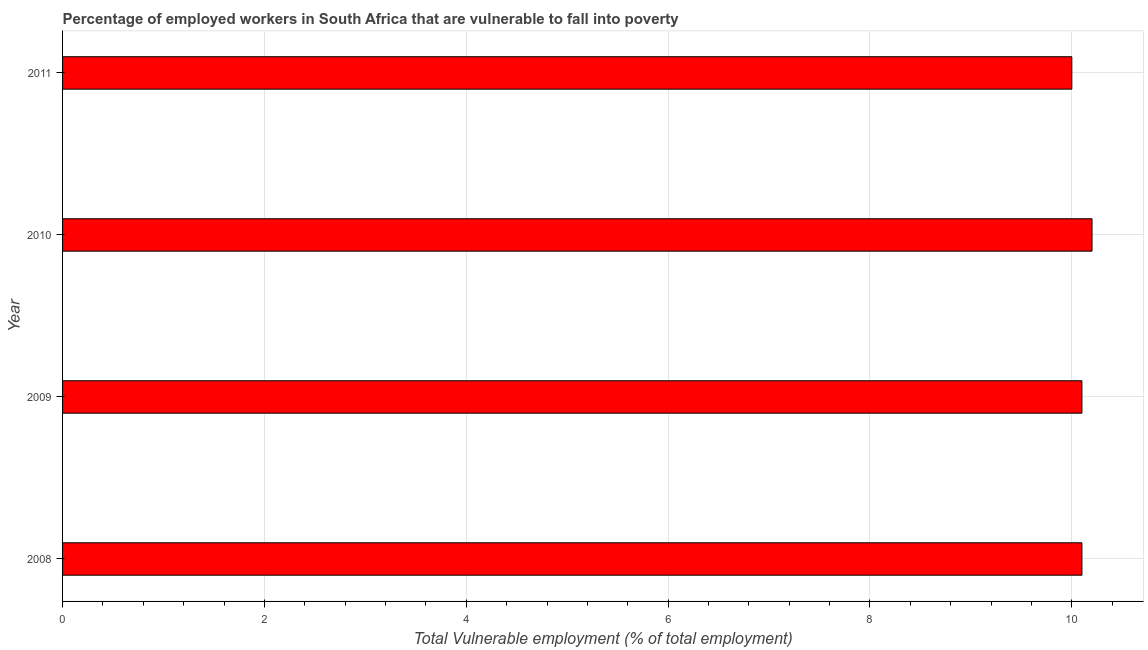Does the graph contain grids?
Provide a short and direct response. Yes. What is the title of the graph?
Offer a very short reply. Percentage of employed workers in South Africa that are vulnerable to fall into poverty. What is the label or title of the X-axis?
Offer a terse response. Total Vulnerable employment (% of total employment). What is the label or title of the Y-axis?
Keep it short and to the point. Year. What is the total vulnerable employment in 2008?
Ensure brevity in your answer.  10.1. Across all years, what is the maximum total vulnerable employment?
Make the answer very short. 10.2. What is the sum of the total vulnerable employment?
Make the answer very short. 40.4. What is the median total vulnerable employment?
Your response must be concise. 10.1. What is the ratio of the total vulnerable employment in 2008 to that in 2011?
Provide a short and direct response. 1.01. What is the difference between the highest and the second highest total vulnerable employment?
Provide a short and direct response. 0.1. Is the sum of the total vulnerable employment in 2010 and 2011 greater than the maximum total vulnerable employment across all years?
Offer a very short reply. Yes. What is the difference between the highest and the lowest total vulnerable employment?
Keep it short and to the point. 0.2. How many bars are there?
Your response must be concise. 4. Are all the bars in the graph horizontal?
Provide a succinct answer. Yes. How many years are there in the graph?
Provide a short and direct response. 4. Are the values on the major ticks of X-axis written in scientific E-notation?
Keep it short and to the point. No. What is the Total Vulnerable employment (% of total employment) of 2008?
Offer a terse response. 10.1. What is the Total Vulnerable employment (% of total employment) in 2009?
Your answer should be compact. 10.1. What is the Total Vulnerable employment (% of total employment) of 2010?
Make the answer very short. 10.2. What is the Total Vulnerable employment (% of total employment) in 2011?
Your response must be concise. 10. What is the difference between the Total Vulnerable employment (% of total employment) in 2008 and 2010?
Provide a succinct answer. -0.1. What is the difference between the Total Vulnerable employment (% of total employment) in 2008 and 2011?
Make the answer very short. 0.1. What is the difference between the Total Vulnerable employment (% of total employment) in 2010 and 2011?
Your answer should be compact. 0.2. What is the ratio of the Total Vulnerable employment (% of total employment) in 2008 to that in 2009?
Offer a very short reply. 1. What is the ratio of the Total Vulnerable employment (% of total employment) in 2008 to that in 2011?
Provide a succinct answer. 1.01. What is the ratio of the Total Vulnerable employment (% of total employment) in 2009 to that in 2010?
Your answer should be compact. 0.99. What is the ratio of the Total Vulnerable employment (% of total employment) in 2010 to that in 2011?
Your answer should be very brief. 1.02. 